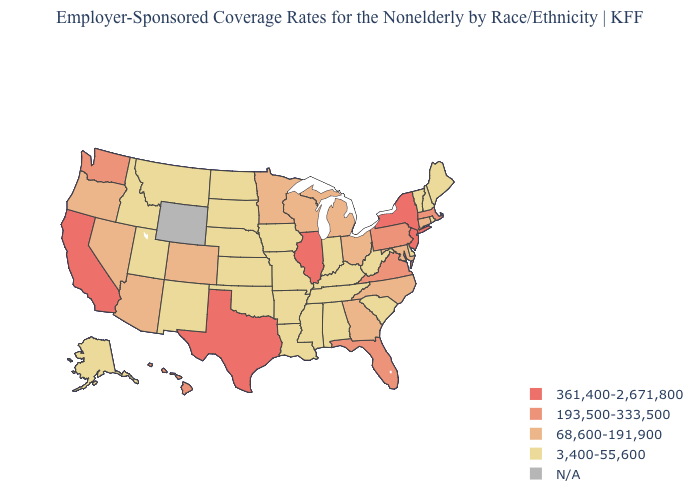Which states have the highest value in the USA?
Concise answer only. California, Illinois, New Jersey, New York, Texas. What is the value of Tennessee?
Answer briefly. 3,400-55,600. What is the highest value in the USA?
Answer briefly. 361,400-2,671,800. Among the states that border Nebraska , does Kansas have the highest value?
Keep it brief. No. What is the highest value in the MidWest ?
Quick response, please. 361,400-2,671,800. Does the first symbol in the legend represent the smallest category?
Quick response, please. No. Which states hav the highest value in the South?
Answer briefly. Texas. What is the value of Washington?
Give a very brief answer. 193,500-333,500. Name the states that have a value in the range 68,600-191,900?
Give a very brief answer. Arizona, Colorado, Connecticut, Georgia, Maryland, Michigan, Minnesota, Nevada, North Carolina, Ohio, Oregon, Wisconsin. Does the first symbol in the legend represent the smallest category?
Write a very short answer. No. What is the value of Texas?
Write a very short answer. 361,400-2,671,800. What is the value of Vermont?
Keep it brief. 3,400-55,600. Among the states that border Georgia , which have the lowest value?
Short answer required. Alabama, South Carolina, Tennessee. Does California have the highest value in the West?
Answer briefly. Yes. 